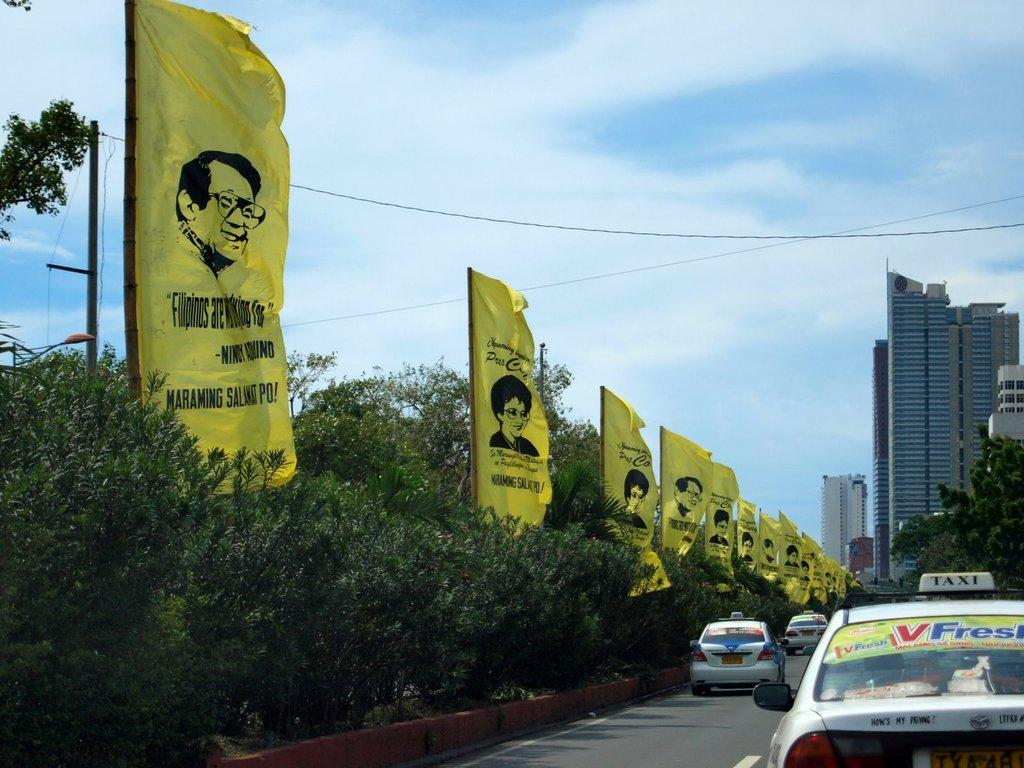Provide a one-sentence caption for the provided image. some flags with one that says Filipinos on it. 